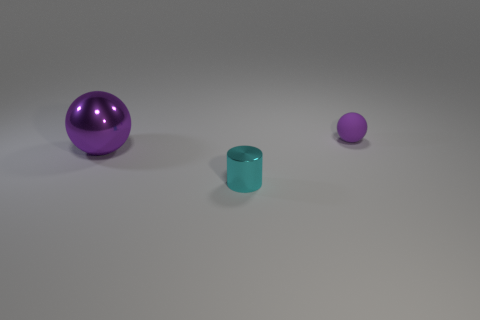Is the cyan thing the same shape as the large purple object?
Give a very brief answer. No. What number of other things are there of the same color as the big metal object?
Offer a very short reply. 1. The small metal cylinder is what color?
Your answer should be compact. Cyan. There is a thing that is on the left side of the tiny purple matte ball and on the right side of the purple metallic ball; how big is it?
Your answer should be compact. Small. What number of objects are purple objects that are behind the big purple ball or cylinders?
Provide a short and direct response. 2. The large object that is made of the same material as the small cyan cylinder is what shape?
Your response must be concise. Sphere. What shape is the cyan shiny thing?
Keep it short and to the point. Cylinder. What is the color of the object that is both in front of the purple rubber object and behind the tiny metal object?
Your answer should be compact. Purple. The cyan metal thing that is the same size as the purple matte ball is what shape?
Keep it short and to the point. Cylinder. Are there any big brown metal objects of the same shape as the small purple rubber object?
Offer a very short reply. No. 